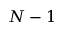<formula> <loc_0><loc_0><loc_500><loc_500>N - 1</formula> 